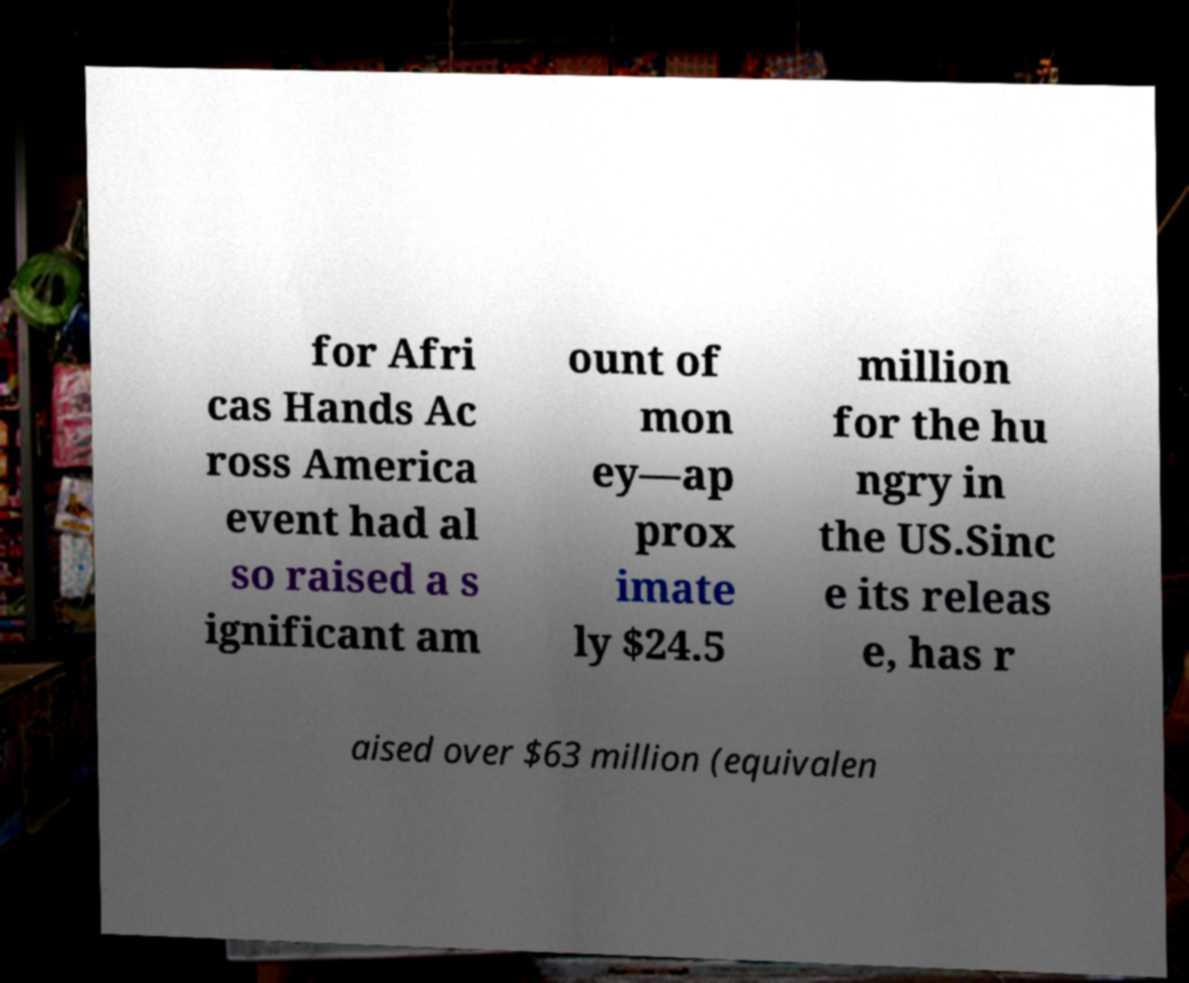Can you accurately transcribe the text from the provided image for me? for Afri cas Hands Ac ross America event had al so raised a s ignificant am ount of mon ey—ap prox imate ly $24.5 million for the hu ngry in the US.Sinc e its releas e, has r aised over $63 million (equivalen 